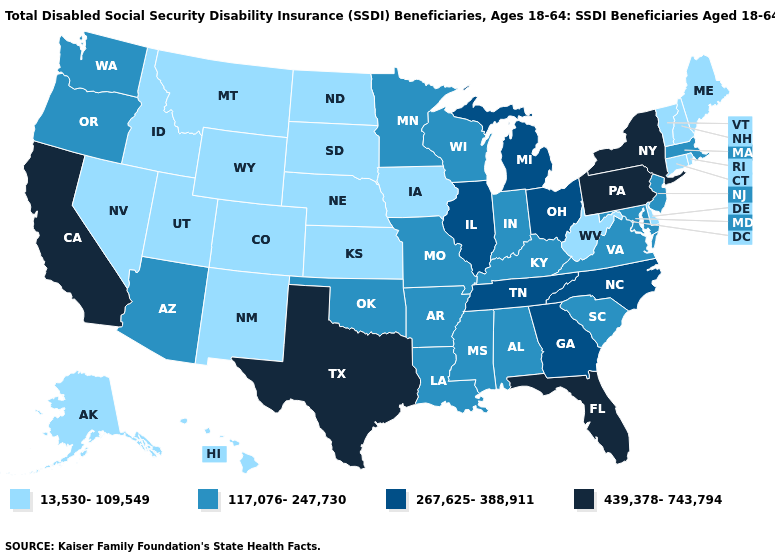How many symbols are there in the legend?
Quick response, please. 4. What is the value of West Virginia?
Quick response, please. 13,530-109,549. Which states have the highest value in the USA?
Keep it brief. California, Florida, New York, Pennsylvania, Texas. What is the value of Arkansas?
Keep it brief. 117,076-247,730. What is the highest value in the West ?
Quick response, please. 439,378-743,794. Does the map have missing data?
Short answer required. No. What is the value of California?
Answer briefly. 439,378-743,794. What is the value of Arizona?
Be succinct. 117,076-247,730. Does the first symbol in the legend represent the smallest category?
Be succinct. Yes. What is the highest value in the South ?
Quick response, please. 439,378-743,794. What is the value of Alabama?
Concise answer only. 117,076-247,730. What is the lowest value in states that border Connecticut?
Concise answer only. 13,530-109,549. What is the value of New Hampshire?
Concise answer only. 13,530-109,549. Does Arizona have the lowest value in the West?
Keep it brief. No. Name the states that have a value in the range 267,625-388,911?
Give a very brief answer. Georgia, Illinois, Michigan, North Carolina, Ohio, Tennessee. 